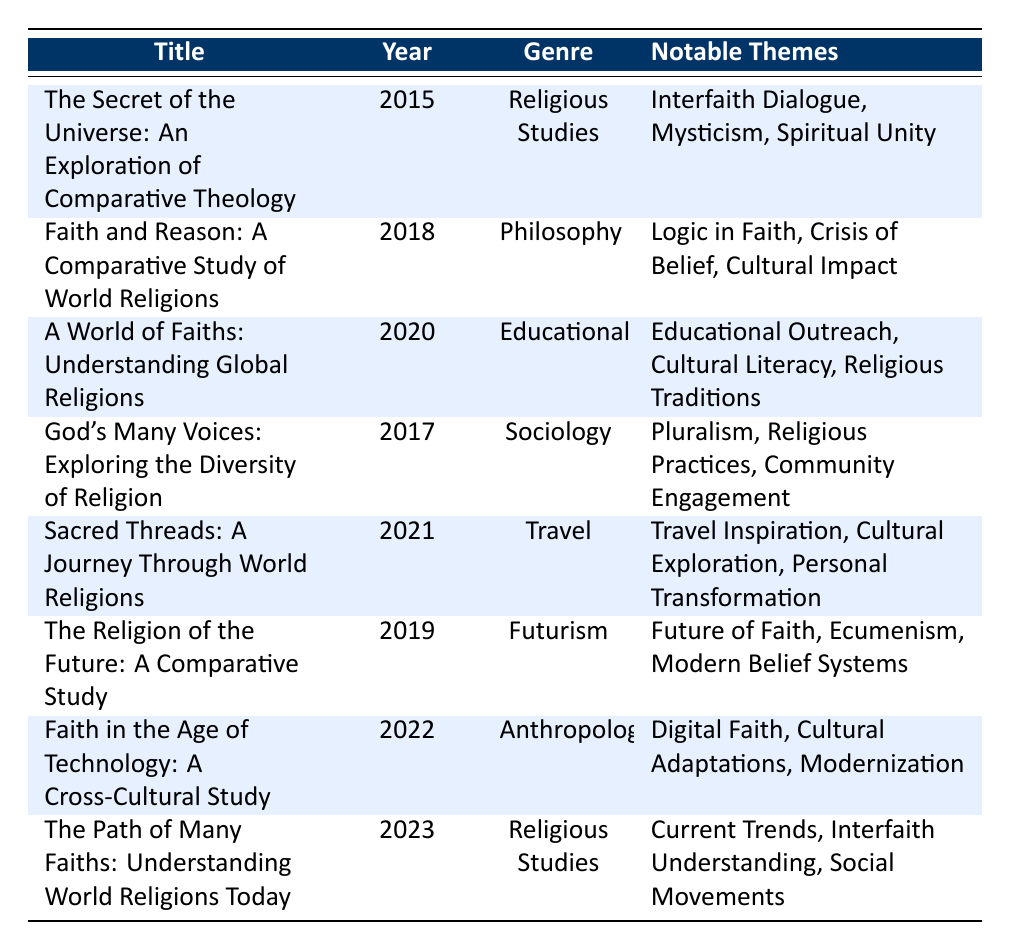What is the title of the book published in 2020? According to the table, the book listed under the year 2020 is "A World of Faiths: Understanding Global Religions."
Answer: A World of Faiths: Understanding Global Religions Which author wrote a book about the future of faith? The table shows that "The Religion of the Future: A Comparative Study" was written by George M. Harris.
Answer: George M. Harris How many books listed focus on Religious Studies? There are two books categorized under Religious Studies: "The Secret of the Universe: An Exploration of Comparative Theology" and "The Path of Many Faiths: Understanding World Religions Today." Adding them gives a total of 2.
Answer: 2 What genres are represented in the table? By checking the genre column, the represented genres include Religious Studies, Philosophy, Educational, Sociology, Travel, Futurism, and Anthropology.
Answer: Religious Studies, Philosophy, Educational, Sociology, Travel, Futurism, Anthropology Is there a book that discusses both cultural impact and logic in faith? The table indicates that the book "Faith and Reason: A Comparative Study of World Religions" discusses themes of logic in faith and cultural impact. Therefore, the answer is yes.
Answer: Yes Which year had the most recent publication? The most recent publication year in the table is 2023, with the book "The Path of Many Faiths: Understanding World Religions Today."
Answer: 2023 Identify a book that addresses interfaith dialogue. The book titled "The Secret of the Universe: An Exploration of Comparative Theology" includes interfaith dialogue as one of its notable themes.
Answer: The Secret of the Universe: An Exploration of Comparative Theology Count the number of books on comparative religion published after 2016. The books published after 2016 are "The Religion of the Future: A Comparative Study" (2019), "Faith and Reason: A Comparative Study of World Religions" (2018), "Faith in the Age of Technology: A Cross-Cultural Study" (2022), and "The Path of Many Faiths: Understanding World Religions Today" (2023). Adding them yields a total of 4.
Answer: 4 Which book emphasizes digital faith? "Faith in the Age of Technology: A Cross-Cultural Study" specifically focuses on the theme of digital faith, as indicated in the notable themes.
Answer: Faith in the Age of Technology: A Cross-Cultural Study Determine the average publication year of all books listed. The publication years are 2015, 2018, 2020, 2017, 2021, 2019, 2022, and 2023. The average is calculated by summing these years (2015 + 2018 + 2020 + 2017 + 2021 + 2019 + 2022 + 2023 = 1615) and dividing by the total number of books (8), giving 2015.
Answer: 2019.375 (which averages between 2019 and 2020) Which themes are common among books on Religious Studies? The common themes in the two Religious Studies books include interfaith dialogue, mysticism, spiritual unity, current trends, interfaith understanding, and social movements. Therefore, there is a blended interest in diversity and understanding across spiritual contexts.
Answer: Interfaith dialogue, mysticism, spiritual unity, current trends, interfaith understanding, social movements 